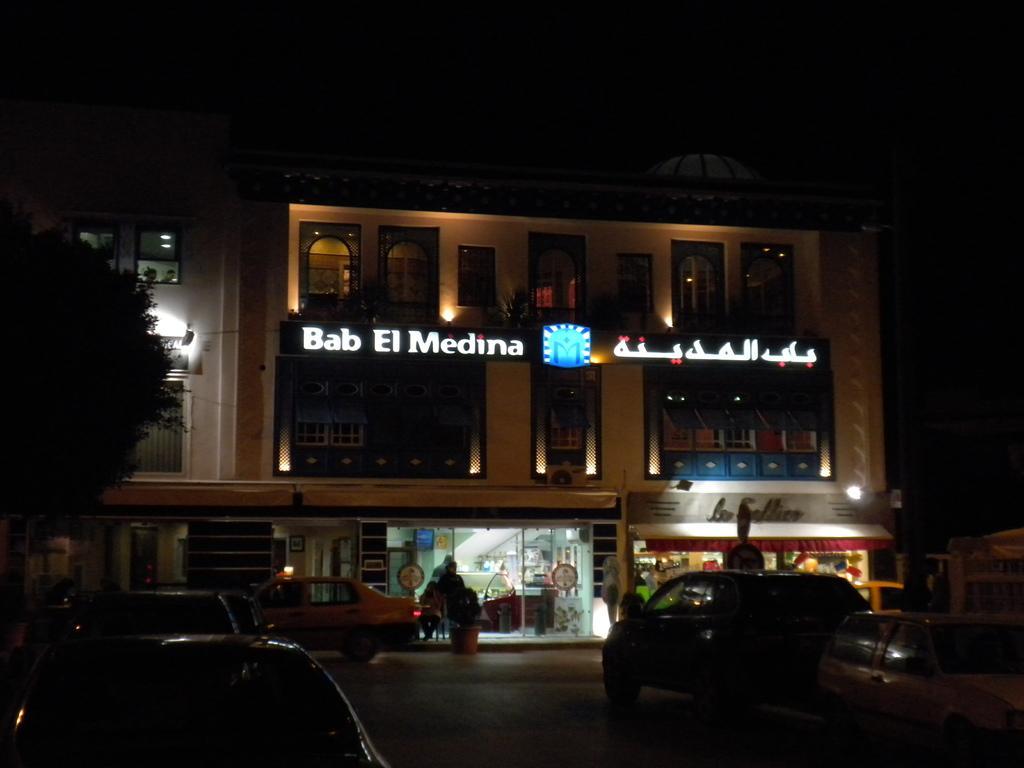In one or two sentences, can you explain what this image depicts? There are many vehicles. In the back there is a building with windows and doors. Also there are lights and something is written on the building. On the left side there is a tree. In the background it is dark 